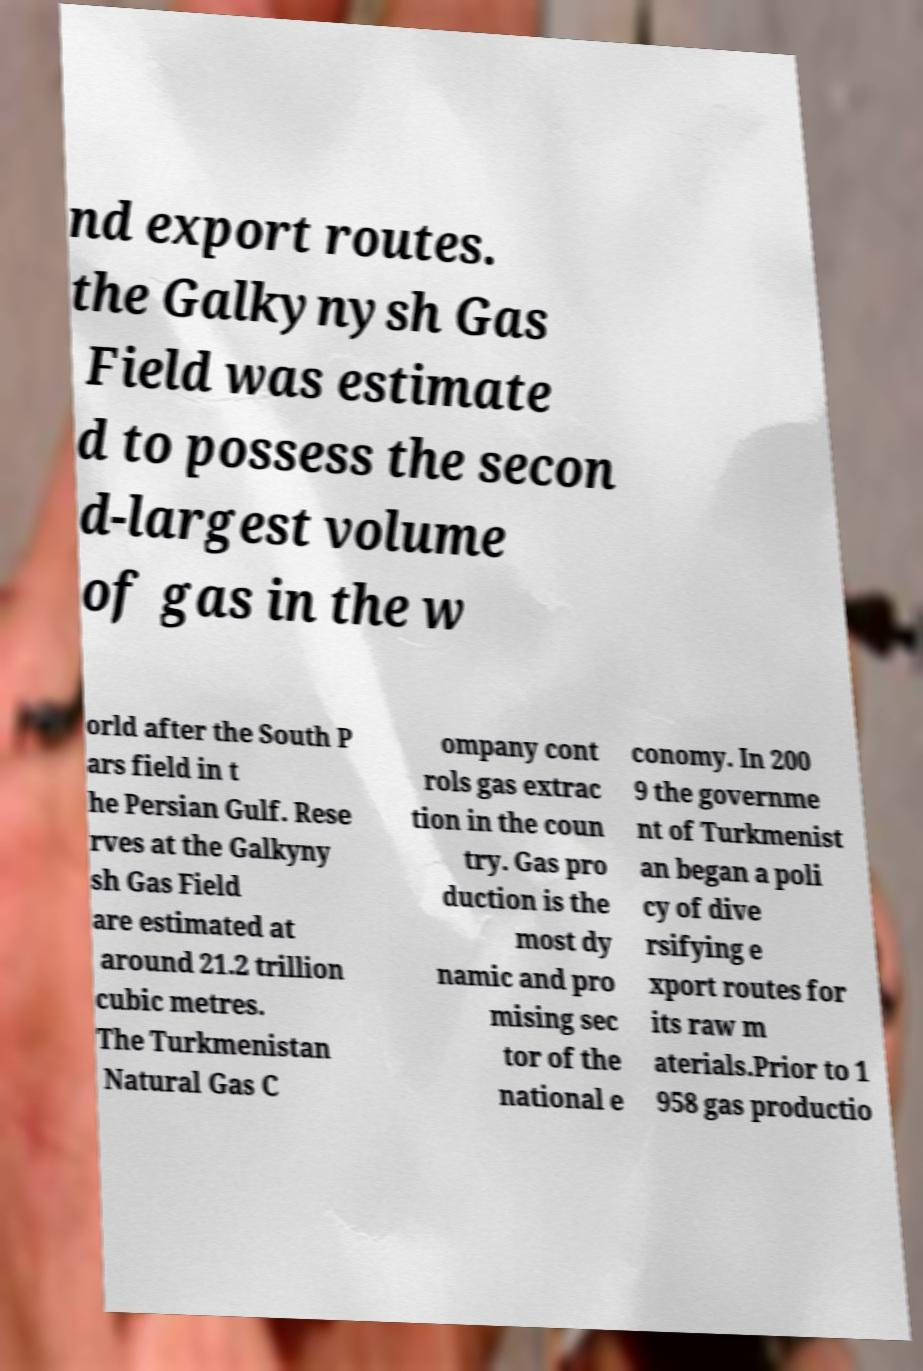What messages or text are displayed in this image? I need them in a readable, typed format. nd export routes. the Galkynysh Gas Field was estimate d to possess the secon d-largest volume of gas in the w orld after the South P ars field in t he Persian Gulf. Rese rves at the Galkyny sh Gas Field are estimated at around 21.2 trillion cubic metres. The Turkmenistan Natural Gas C ompany cont rols gas extrac tion in the coun try. Gas pro duction is the most dy namic and pro mising sec tor of the national e conomy. In 200 9 the governme nt of Turkmenist an began a poli cy of dive rsifying e xport routes for its raw m aterials.Prior to 1 958 gas productio 